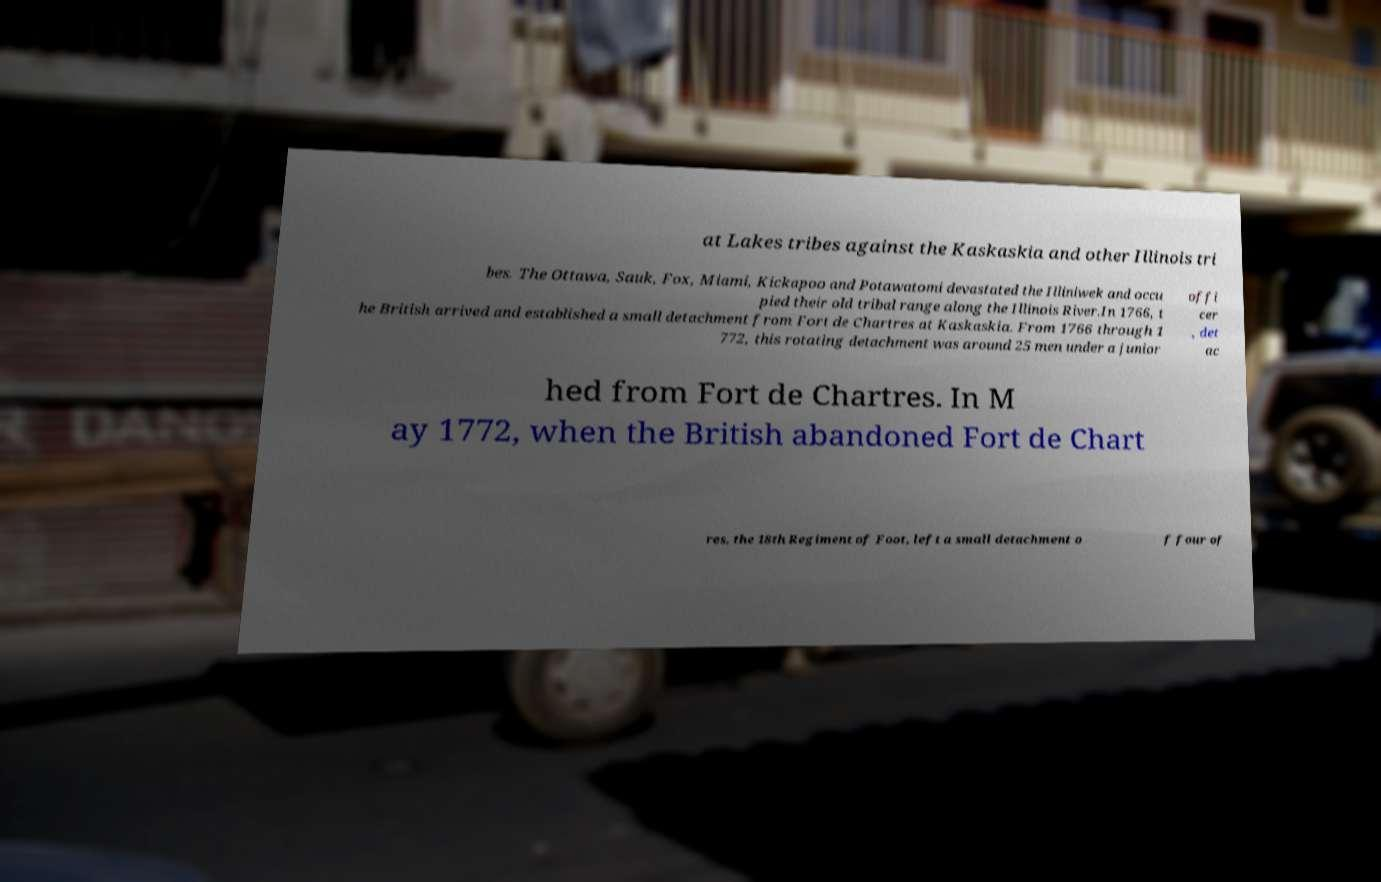Could you assist in decoding the text presented in this image and type it out clearly? at Lakes tribes against the Kaskaskia and other Illinois tri bes. The Ottawa, Sauk, Fox, Miami, Kickapoo and Potawatomi devastated the Illiniwek and occu pied their old tribal range along the Illinois River.In 1766, t he British arrived and established a small detachment from Fort de Chartres at Kaskaskia. From 1766 through 1 772, this rotating detachment was around 25 men under a junior offi cer , det ac hed from Fort de Chartres. In M ay 1772, when the British abandoned Fort de Chart res, the 18th Regiment of Foot, left a small detachment o f four of 